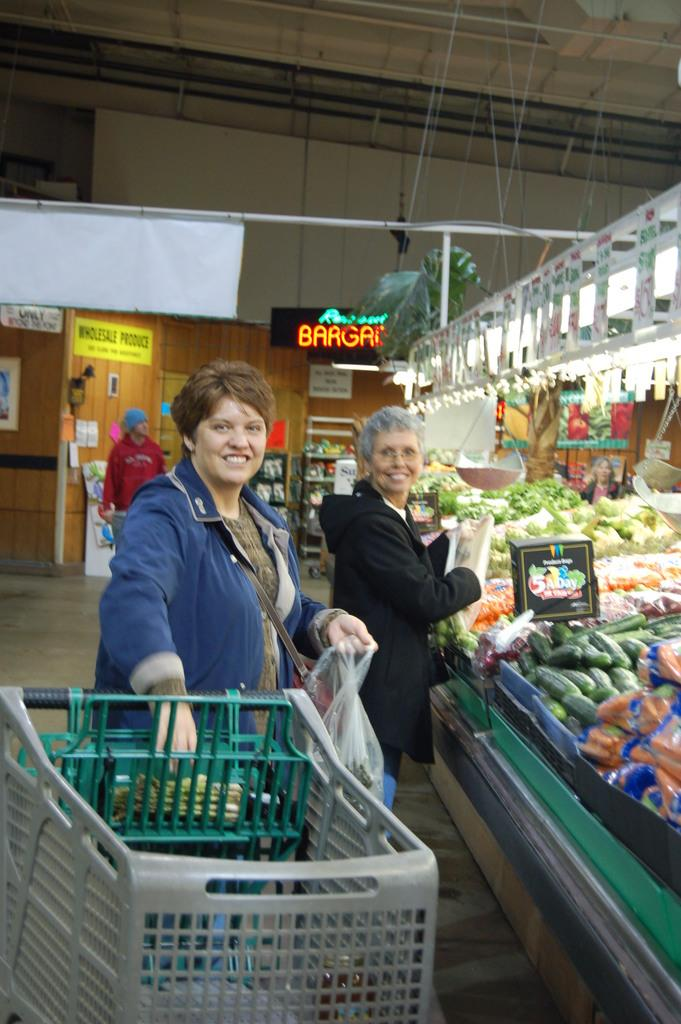<image>
Describe the image concisely. Two ladies standing in grocery store below a Bar garden sign 